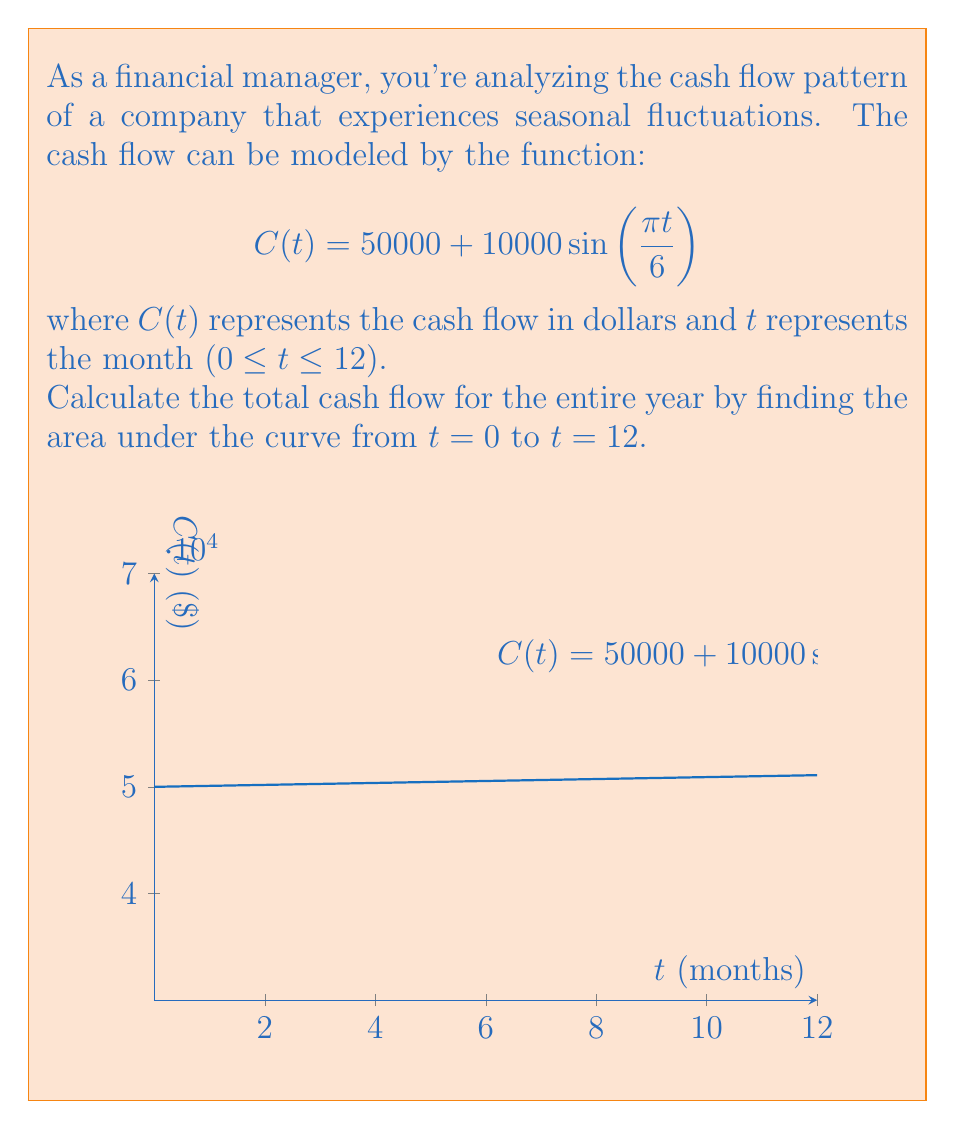Could you help me with this problem? To find the total cash flow for the year, we need to calculate the definite integral of the function $C(t)$ from 0 to 12.

Step 1: Set up the integral
$$\int_0^{12} C(t) dt = \int_0^{12} (50000 + 10000 \sin(\frac{\pi t}{6})) dt$$

Step 2: Separate the integral
$$\int_0^{12} 50000 dt + \int_0^{12} 10000 \sin(\frac{\pi t}{6}) dt$$

Step 3: Evaluate the first integral
$$50000t \Big|_0^{12} = 600000$$

Step 4: Evaluate the second integral using the formula $\int \sin(ax) dx = -\frac{1}{a}\cos(ax) + C$
$$10000 \cdot (-\frac{6}{\pi}) \cos(\frac{\pi t}{6}) \Big|_0^{12}$$

Step 5: Calculate the result of the second integral
$$= -\frac{60000}{\pi} [\cos(2\pi) - \cos(0)] = -\frac{60000}{\pi} [1 - 1] = 0$$

Step 6: Sum up the results
Total cash flow = $600000 + 0 = 600000$

Therefore, the total cash flow for the year is $600,000.
Answer: $600,000 